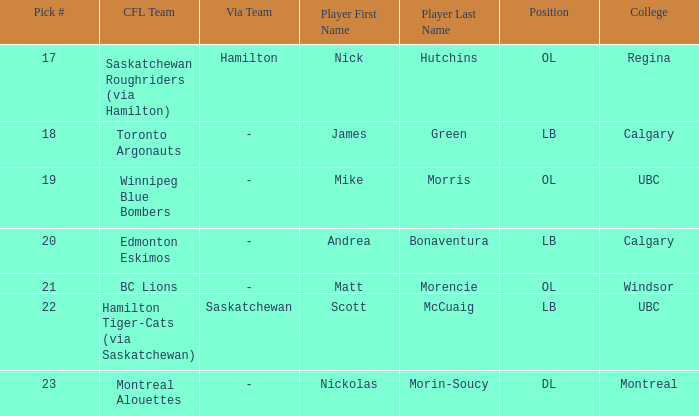What position is the player who went to Regina?  OL. 